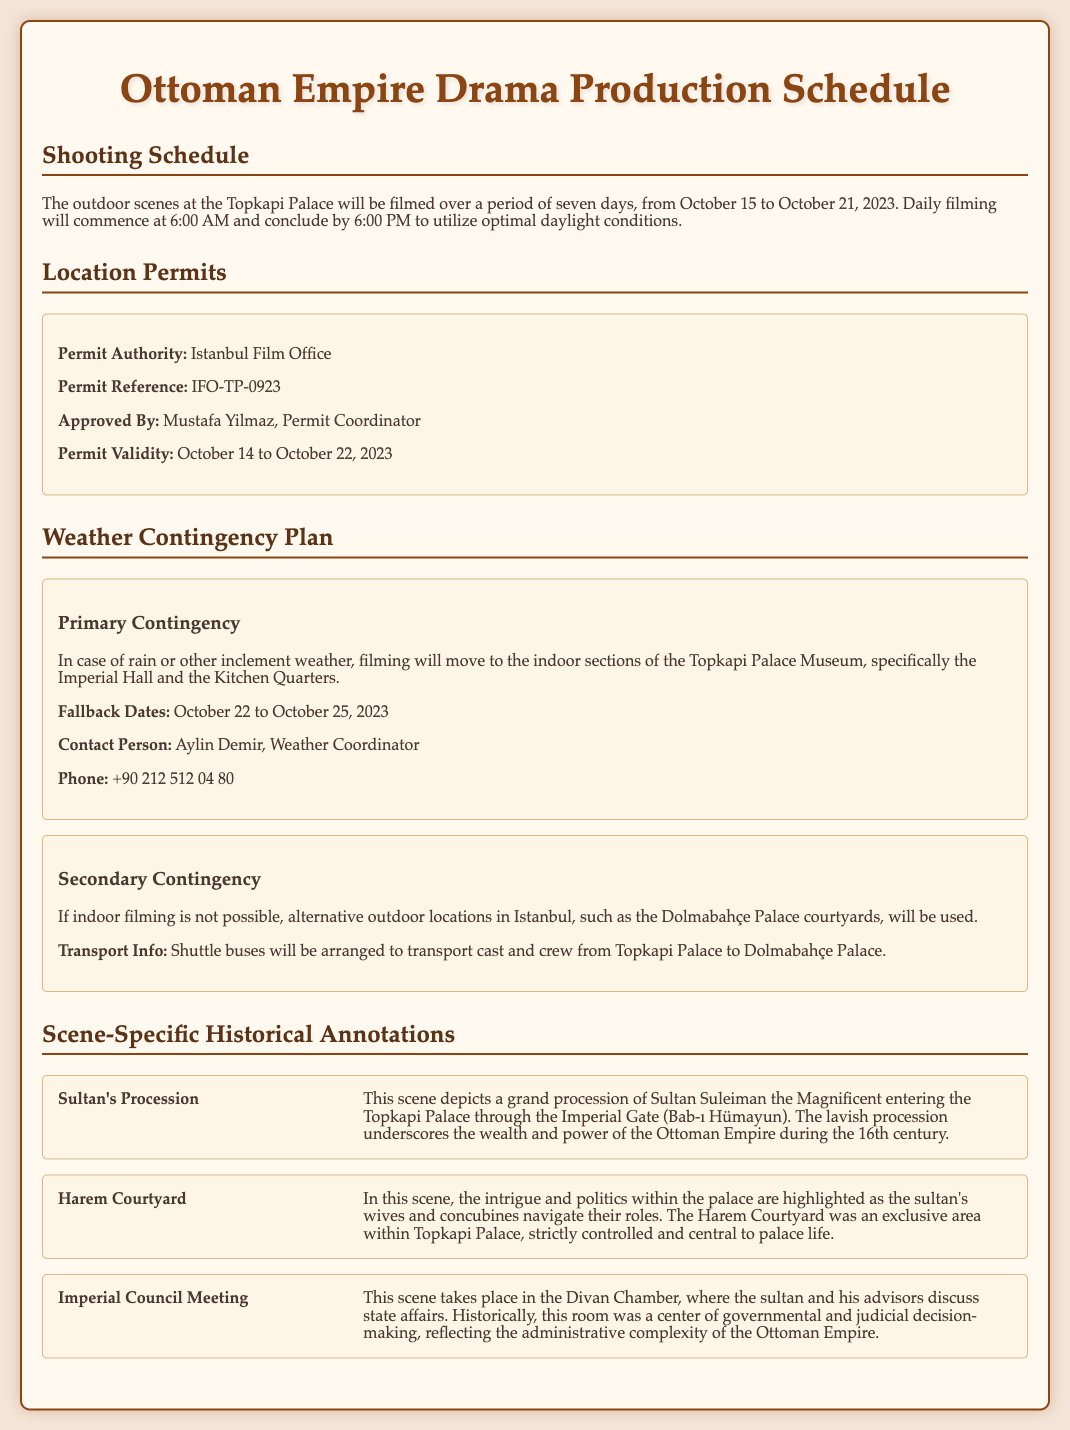What are the filming dates for the outdoor scenes? The outdoor scenes will be filmed from October 15 to October 21, 2023.
Answer: October 15 to October 21, 2023 Who approved the location permit? The permit was approved by Mustafa Yilmaz, who is the Permit Coordinator.
Answer: Mustafa Yilmaz What is the primary contingency plan for bad weather? Filming will move to the indoor sections of the Topkapi Palace Museum, specifically the Imperial Hall and the Kitchen Quarters.
Answer: Indoor sections of the Topkapi Palace What is the contact person for the weather contingency plan? The contact person for the weather contingency plan is Aylin Demir.
Answer: Aylin Demir What scene shows the entrance of Sultan Suleiman the Magnificent? The scene depicting this event is the Sultan's Procession.
Answer: Sultan's Procession How many total days will the outdoor shooting take place? The outdoor shooting will take place over a period of seven days.
Answer: Seven days What is the permit validity period? The permit is valid from October 14 to October 22, 2023.
Answer: October 14 to October 22, 2023 Where will filming take place if the indoor filming is not possible? Alternative outdoor locations in Istanbul, such as the Dolmabahçe Palace courtyards, will be used.
Answer: Dolmabahçe Palace courtyards 